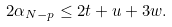<formula> <loc_0><loc_0><loc_500><loc_500>2 \alpha _ { N - p } \leq 2 t + u + 3 w .</formula> 